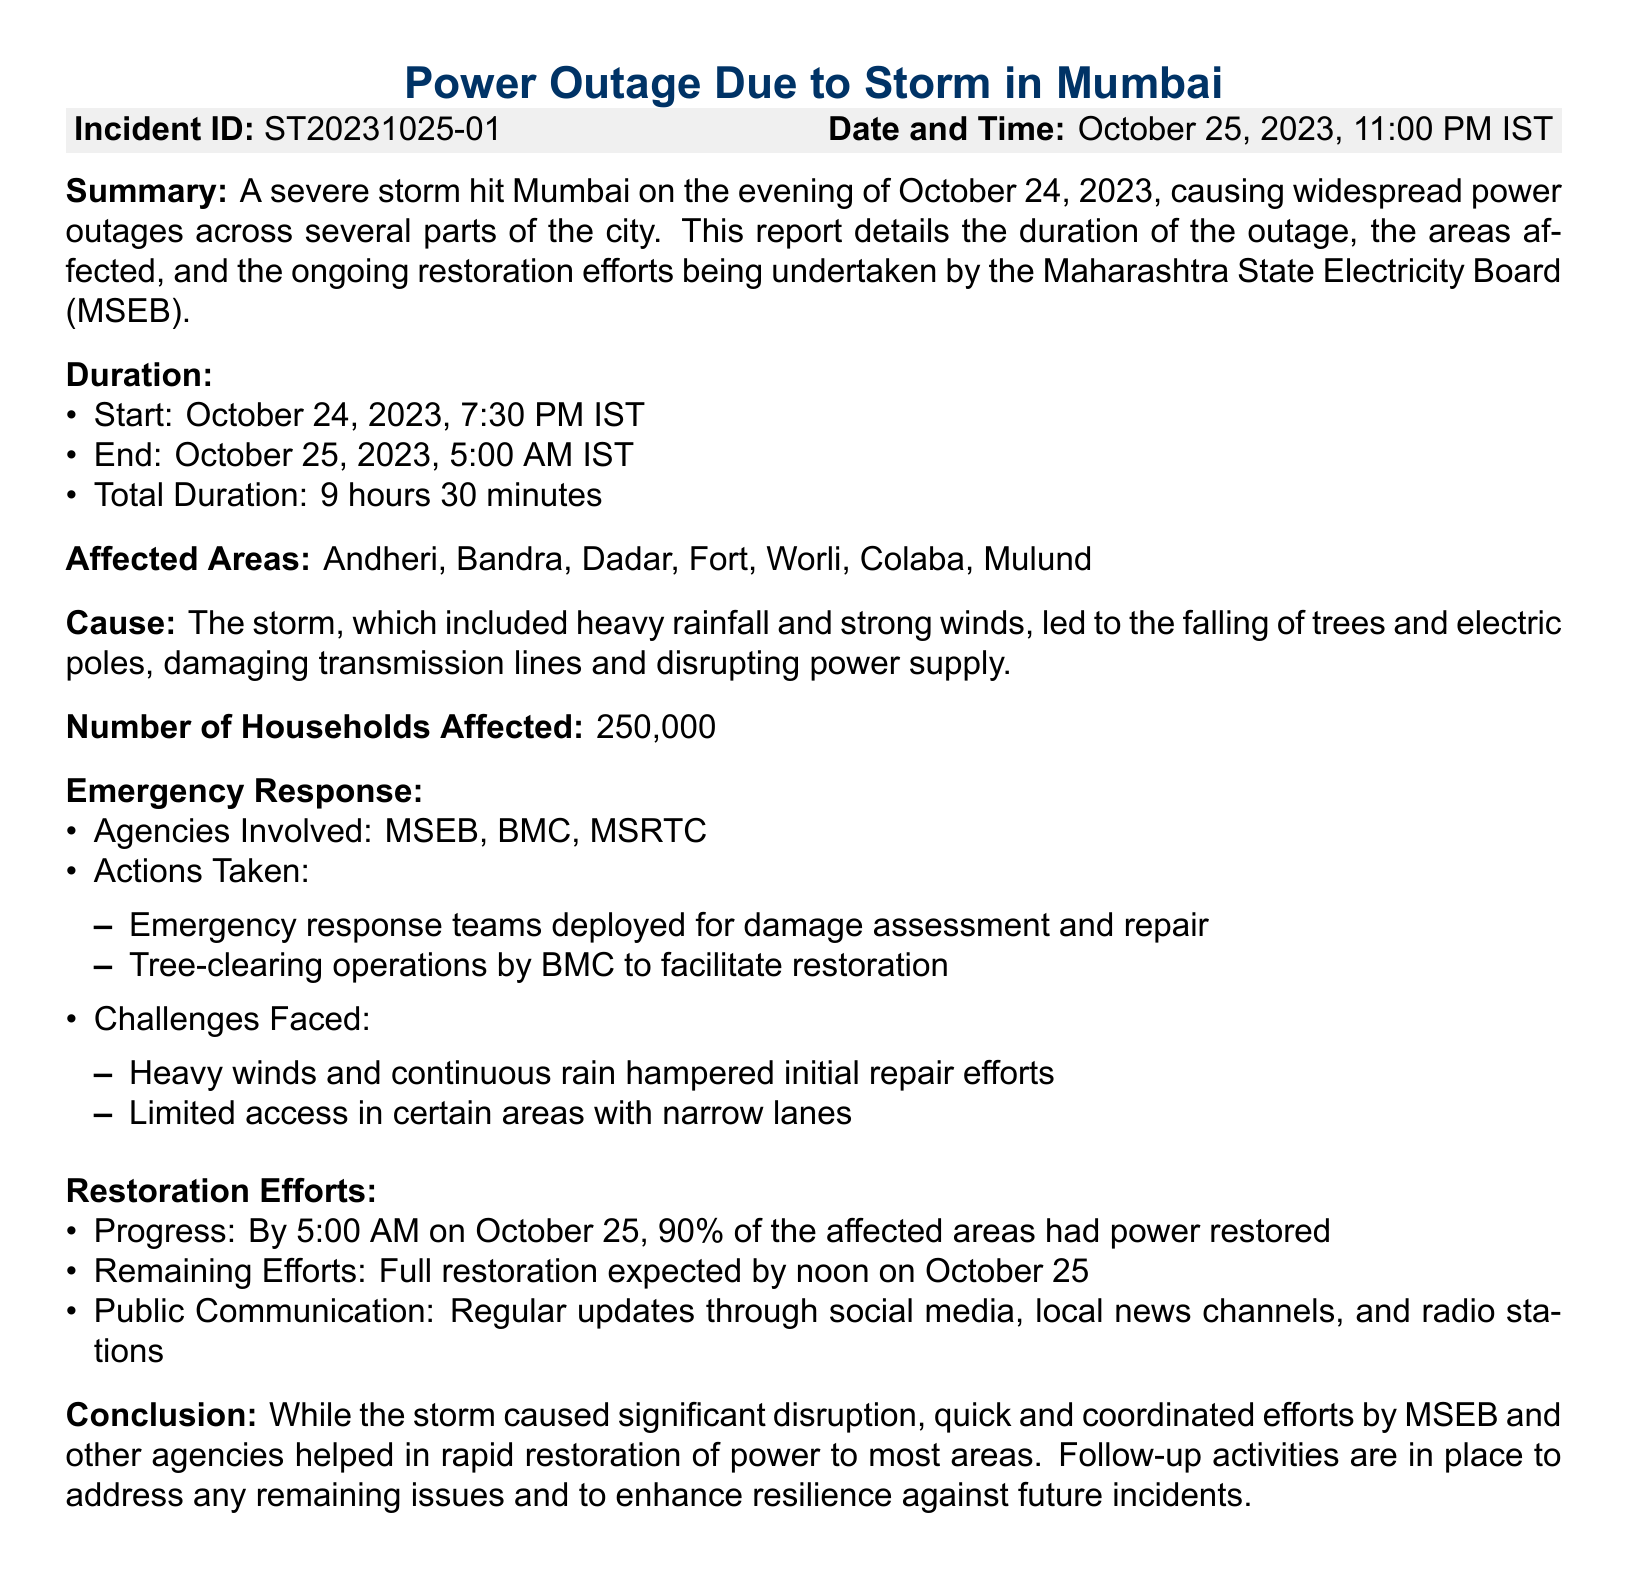What was the duration of the power outage? The duration of the power outage is derived from the start and end times provided in the report, which is October 24, 2023, 7:30 PM IST to October 25, 2023, 5:00 AM IST, totaling 9 hours 30 minutes.
Answer: 9 hours 30 minutes Which agency is primarily responsible for the restoration efforts? The primary agency responsible for the restoration efforts mentioned in the report is the Maharashtra State Electricity Board (MSEB).
Answer: MSEB How many households were affected by the outage? The number of households affected is explicitly stated in the report as 250,000.
Answer: 250,000 What was one of the causes of the power outage? The report identifies the cause of the power outage as the storm leading to falling of trees and electric poles, affecting transmission lines and power supply.
Answer: Falling of trees and electric poles By what time was 90% of the affected areas restored? According to the report, by 5:00 AM on October 25, 90% of the affected areas had power restored.
Answer: 5:00 AM What challenges were faced during the restoration efforts? The report lists challenges such as heavy winds and continuous rain that hampered repair efforts, along with limited access in narrow lanes as obstacles encountered during restoration.
Answer: Heavy winds and continuous rain When did the storm that caused the power outage occur? The storm that led to the power outage hit Mumbai in the evening of October 24, 2023.
Answer: October 24, 2023 What are the ongoing activities for future resilience mentioned in the report? The report indicates that follow-up activities are in place to address any remaining issues and enhance resilience against future incidents after the storm.
Answer: Follow-up activities 